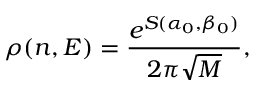<formula> <loc_0><loc_0><loc_500><loc_500>\rho ( n , E ) = \frac { e ^ { S ( \alpha _ { 0 } , \beta _ { 0 } ) } } { 2 \pi \sqrt { M } } ,</formula> 